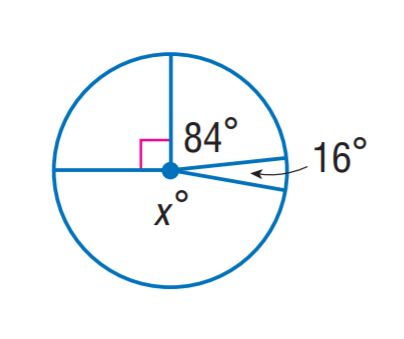Question: Find x.
Choices:
A. 168
B. 170
C. 172
D. 174
Answer with the letter. Answer: B 